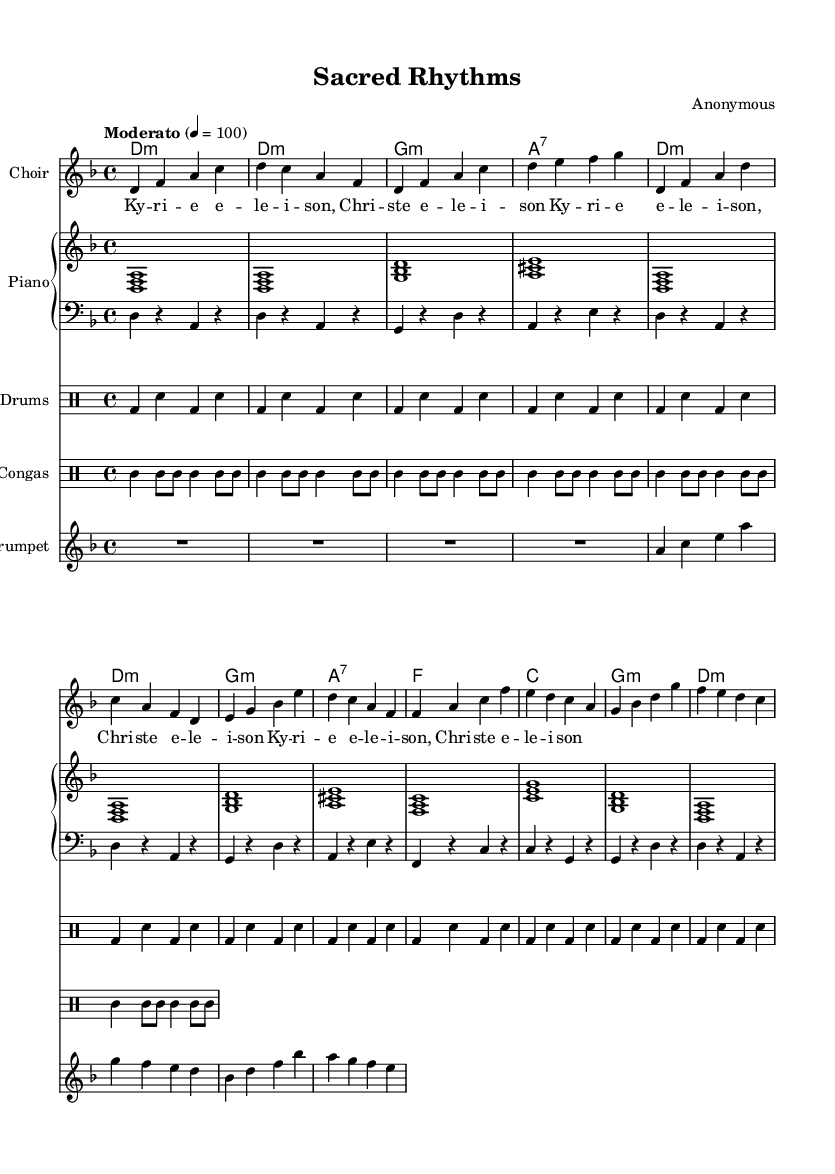What is the key signature of this music? The key signature is indicated by the sharps or flats at the beginning of the staff. In this case, there are no sharps or flats, which corresponds to D minor for the minor scale option.
Answer: D minor What is the time signature of this music? The time signature is indicated at the beginning of the music and is represented by the two numbers stacked vertically. Here it is 4 over 4, meaning there are 4 beats per measure.
Answer: 4/4 What is the tempo marking of this music? The tempo marking is given at the beginning in the global section. It is indicated with "Moderato" followed by a metronome marking of 100 beats per minute.
Answer: Moderato 4 = 100 How many measures are present in the choir part? The number of measures is calculated by counting the number of vertical bar lines in the choir staff. There are a total of 12 bars in the choir section.
Answer: 12 measures What is the first note in the trumpet part? The first note is identified by looking at the initial pitch notated in the trumpet staff. The first note is an A in the second octave (a).
Answer: A What rhythmic pattern do the drums follow in the first measure? The first measure for the drum part shows a bass drum on beat 1 and 3, combined with a snare drum on beats 2 and 4, creating a basic backbeat pattern.
Answer: Bass-Snare-Snare Which sacred chant is incorporated in the choir lyrics? The lyrics comprise repeated phrases that include "Kyriê eleison, Christe eleison," a well-known sacred chant meaning "Lord, have mercy; Christ, have mercy."
Answer: Kyriê eleison 